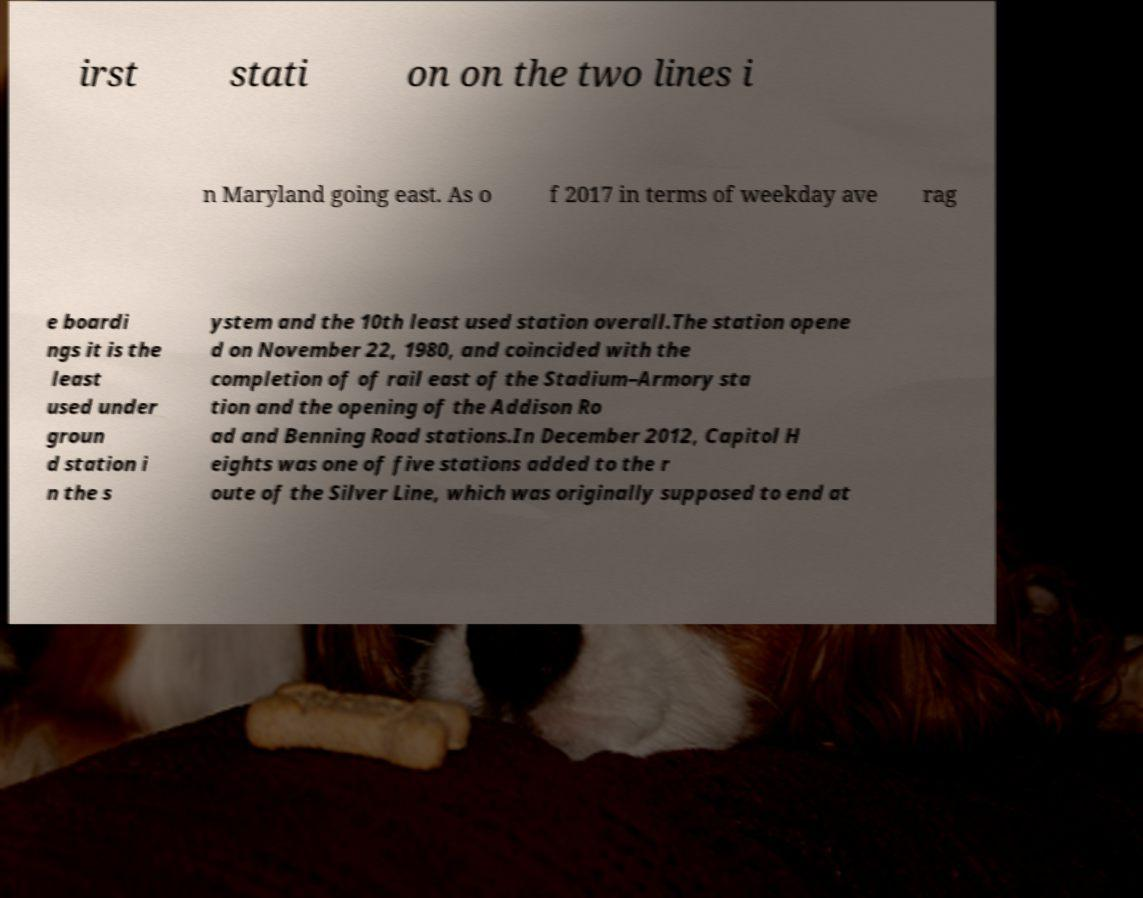Could you assist in decoding the text presented in this image and type it out clearly? irst stati on on the two lines i n Maryland going east. As o f 2017 in terms of weekday ave rag e boardi ngs it is the least used under groun d station i n the s ystem and the 10th least used station overall.The station opene d on November 22, 1980, and coincided with the completion of of rail east of the Stadium–Armory sta tion and the opening of the Addison Ro ad and Benning Road stations.In December 2012, Capitol H eights was one of five stations added to the r oute of the Silver Line, which was originally supposed to end at 